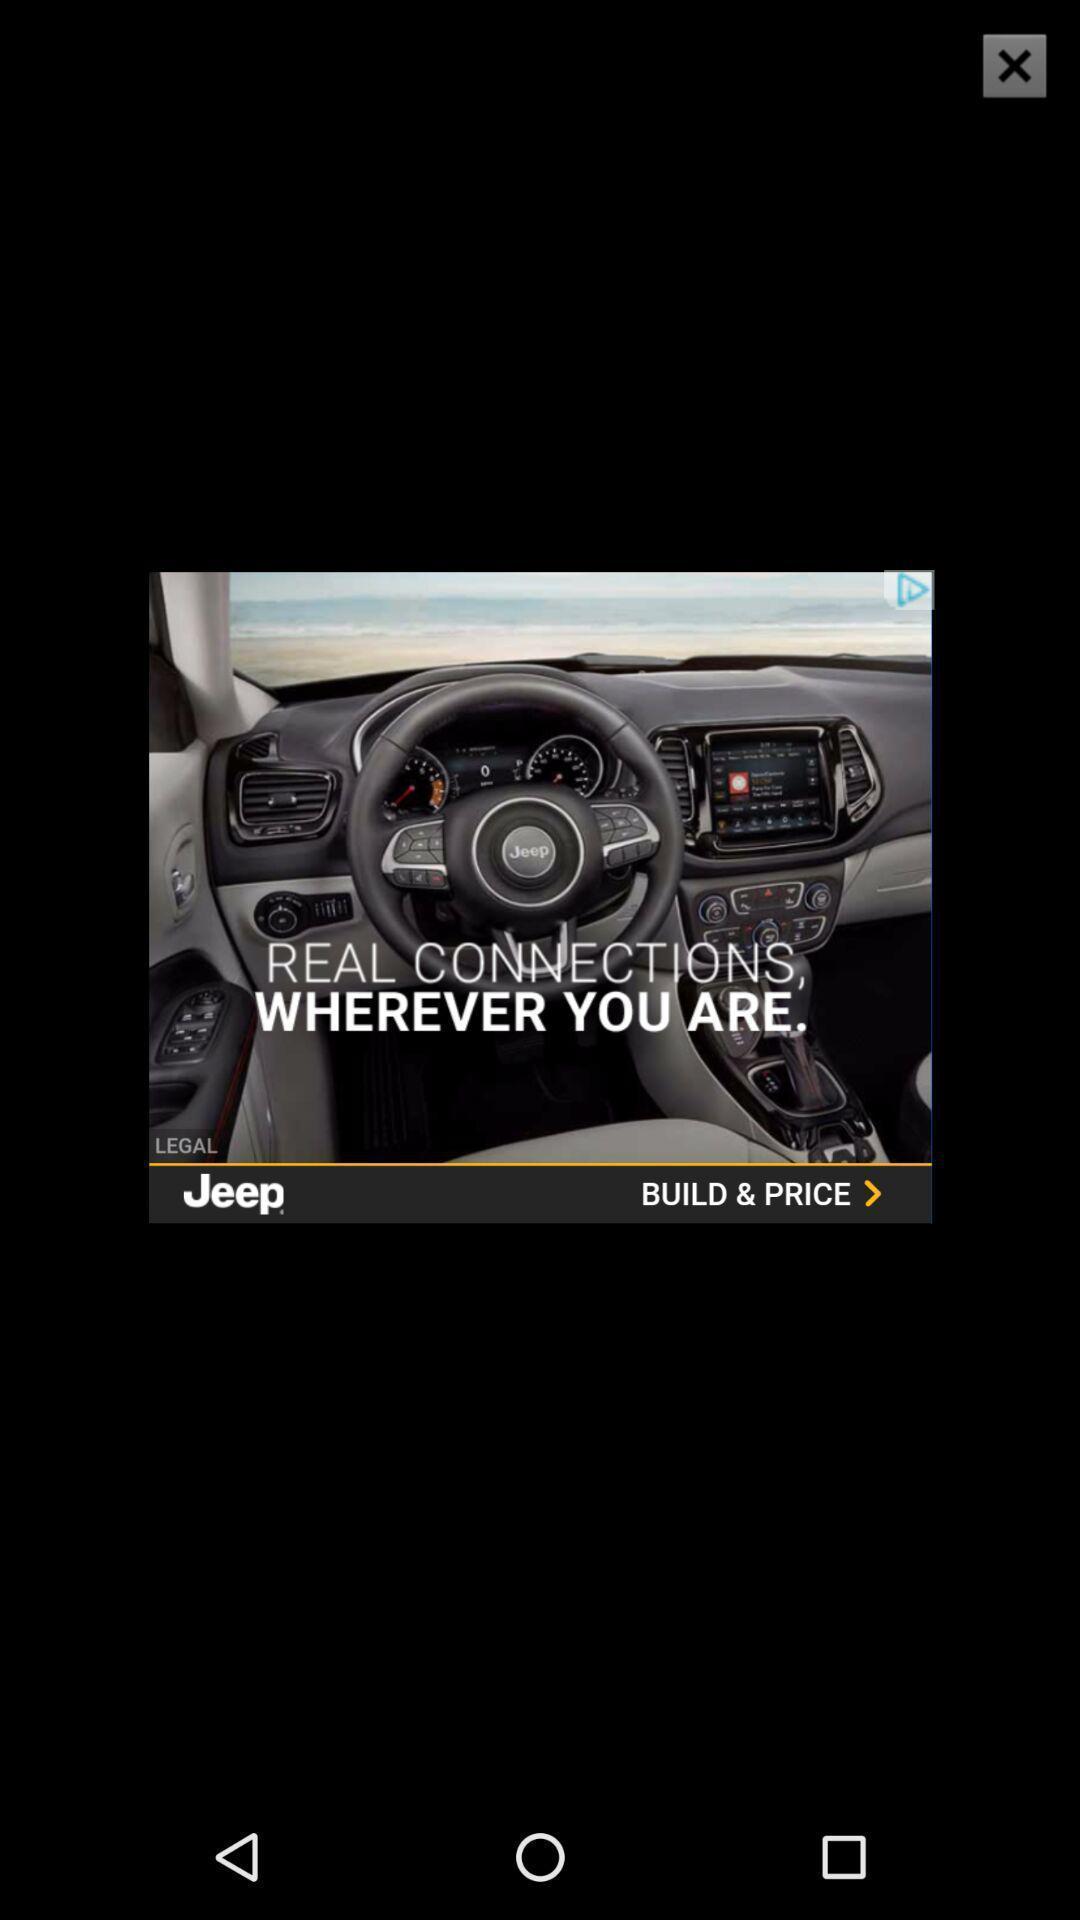Tell me about the visual elements in this screen capture. Pop-up showing a car advertisement. 